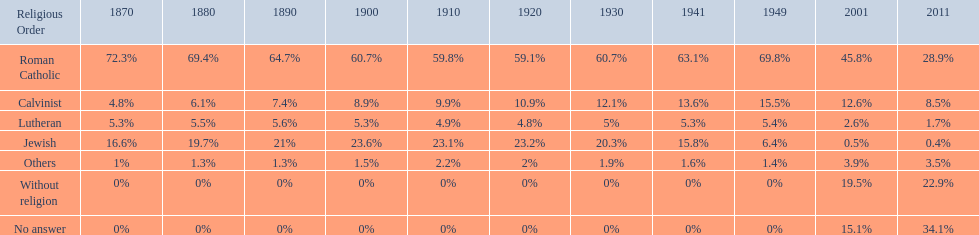Which religious denomination had a higher percentage in 1900, jewish or roman catholic? Roman Catholic. 